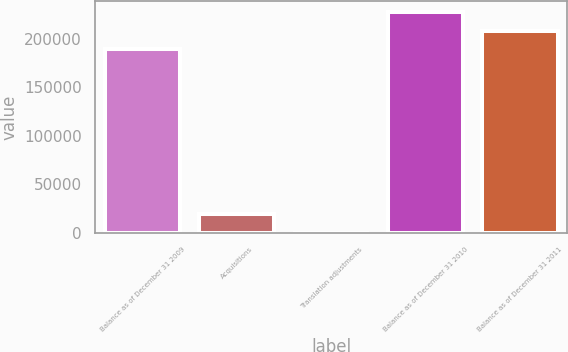<chart> <loc_0><loc_0><loc_500><loc_500><bar_chart><fcel>Balance as of December 31 2009<fcel>Acquisitions<fcel>Translation adjustments<fcel>Balance as of December 31 2010<fcel>Balance as of December 31 2011<nl><fcel>189336<fcel>19140.7<fcel>180<fcel>227257<fcel>208297<nl></chart> 